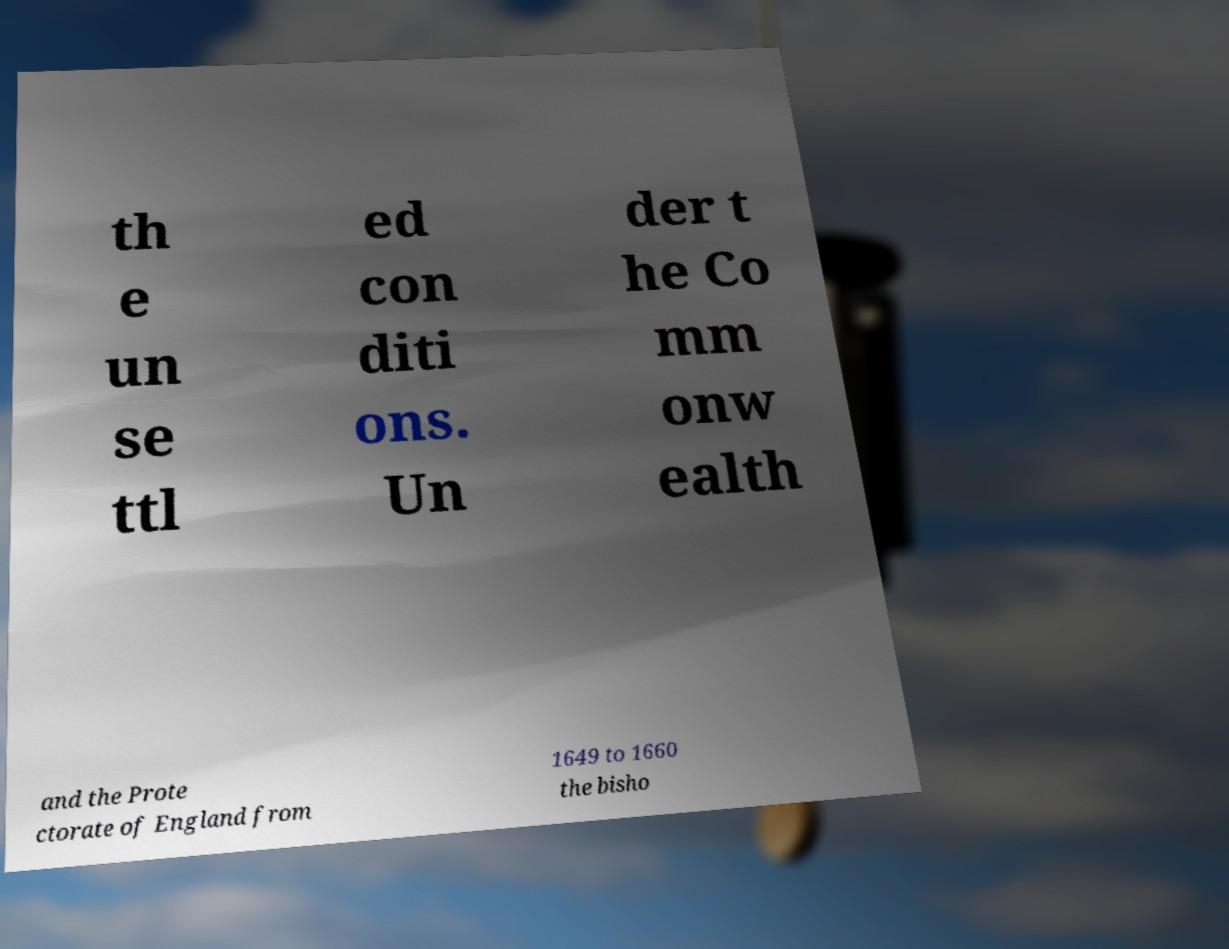What messages or text are displayed in this image? I need them in a readable, typed format. th e un se ttl ed con diti ons. Un der t he Co mm onw ealth and the Prote ctorate of England from 1649 to 1660 the bisho 